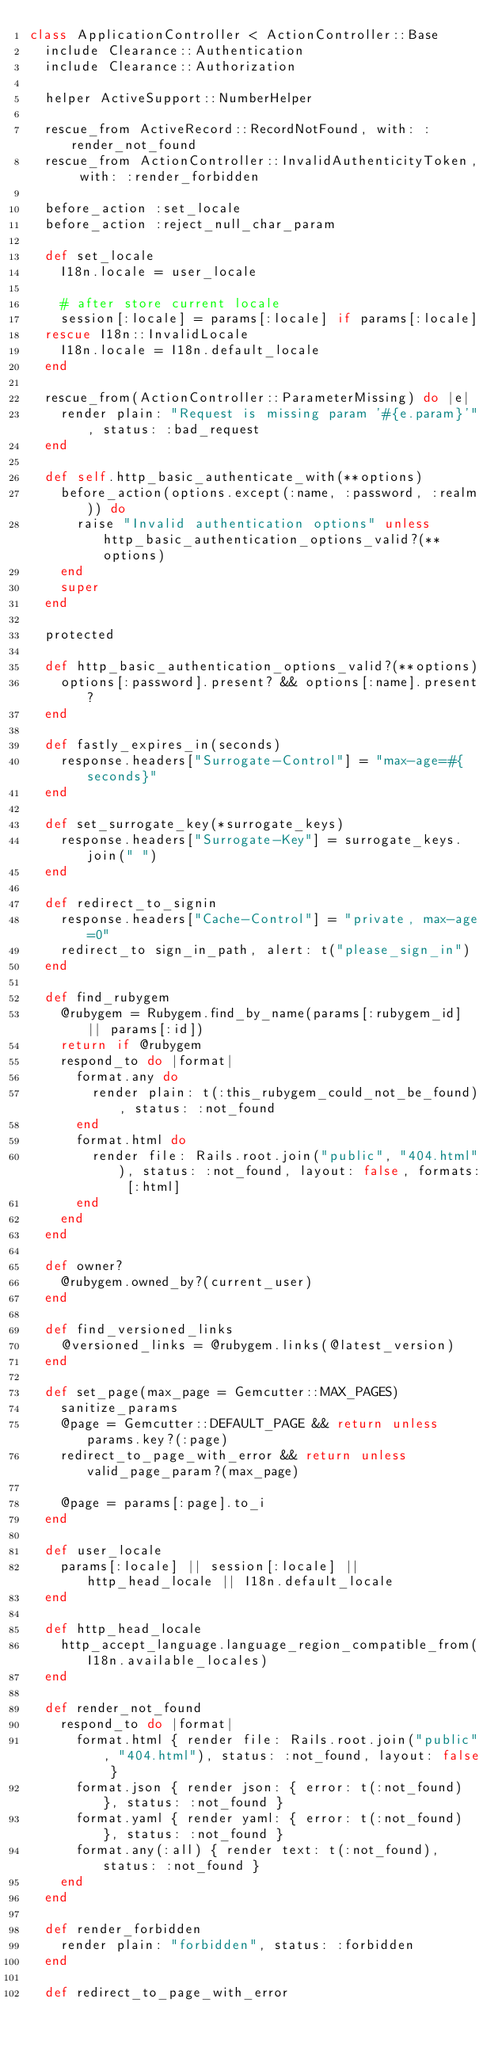Convert code to text. <code><loc_0><loc_0><loc_500><loc_500><_Ruby_>class ApplicationController < ActionController::Base
  include Clearance::Authentication
  include Clearance::Authorization

  helper ActiveSupport::NumberHelper

  rescue_from ActiveRecord::RecordNotFound, with: :render_not_found
  rescue_from ActionController::InvalidAuthenticityToken, with: :render_forbidden

  before_action :set_locale
  before_action :reject_null_char_param

  def set_locale
    I18n.locale = user_locale

    # after store current locale
    session[:locale] = params[:locale] if params[:locale]
  rescue I18n::InvalidLocale
    I18n.locale = I18n.default_locale
  end

  rescue_from(ActionController::ParameterMissing) do |e|
    render plain: "Request is missing param '#{e.param}'", status: :bad_request
  end

  def self.http_basic_authenticate_with(**options)
    before_action(options.except(:name, :password, :realm)) do
      raise "Invalid authentication options" unless http_basic_authentication_options_valid?(**options)
    end
    super
  end

  protected

  def http_basic_authentication_options_valid?(**options)
    options[:password].present? && options[:name].present?
  end

  def fastly_expires_in(seconds)
    response.headers["Surrogate-Control"] = "max-age=#{seconds}"
  end

  def set_surrogate_key(*surrogate_keys)
    response.headers["Surrogate-Key"] = surrogate_keys.join(" ")
  end

  def redirect_to_signin
    response.headers["Cache-Control"] = "private, max-age=0"
    redirect_to sign_in_path, alert: t("please_sign_in")
  end

  def find_rubygem
    @rubygem = Rubygem.find_by_name(params[:rubygem_id] || params[:id])
    return if @rubygem
    respond_to do |format|
      format.any do
        render plain: t(:this_rubygem_could_not_be_found), status: :not_found
      end
      format.html do
        render file: Rails.root.join("public", "404.html"), status: :not_found, layout: false, formats: [:html]
      end
    end
  end

  def owner?
    @rubygem.owned_by?(current_user)
  end

  def find_versioned_links
    @versioned_links = @rubygem.links(@latest_version)
  end

  def set_page(max_page = Gemcutter::MAX_PAGES)
    sanitize_params
    @page = Gemcutter::DEFAULT_PAGE && return unless params.key?(:page)
    redirect_to_page_with_error && return unless valid_page_param?(max_page)

    @page = params[:page].to_i
  end

  def user_locale
    params[:locale] || session[:locale] || http_head_locale || I18n.default_locale
  end

  def http_head_locale
    http_accept_language.language_region_compatible_from(I18n.available_locales)
  end

  def render_not_found
    respond_to do |format|
      format.html { render file: Rails.root.join("public", "404.html"), status: :not_found, layout: false }
      format.json { render json: { error: t(:not_found) }, status: :not_found }
      format.yaml { render yaml: { error: t(:not_found) }, status: :not_found }
      format.any(:all) { render text: t(:not_found), status: :not_found }
    end
  end

  def render_forbidden
    render plain: "forbidden", status: :forbidden
  end

  def redirect_to_page_with_error</code> 